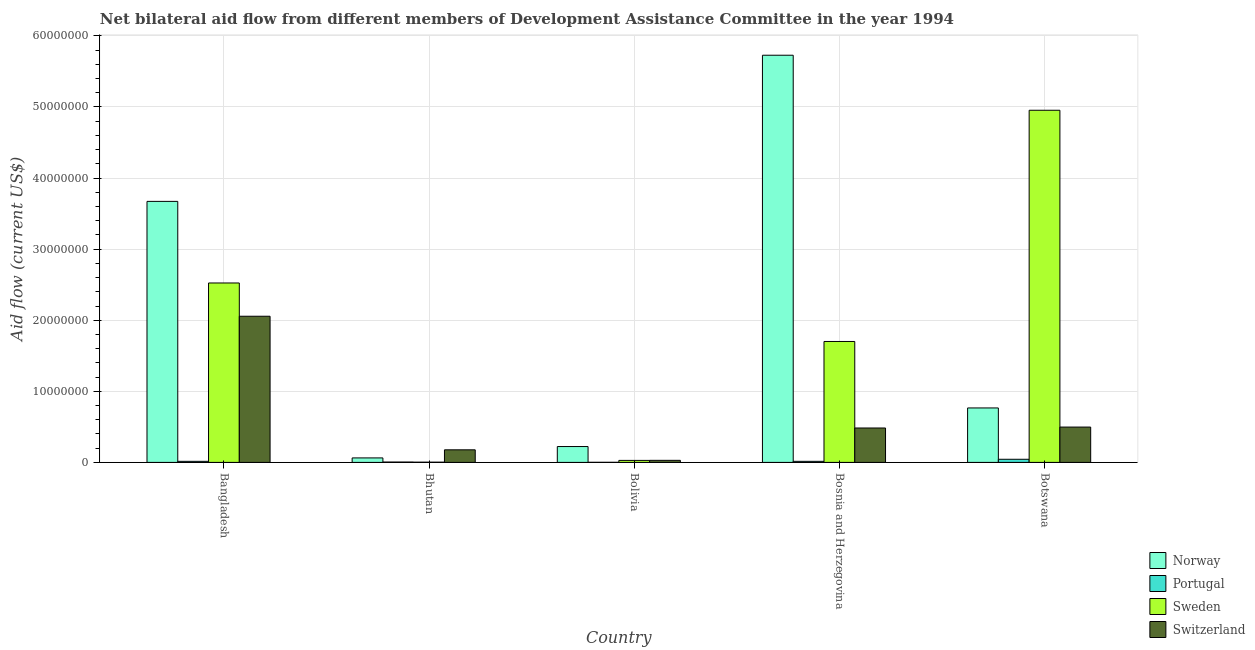How many different coloured bars are there?
Your answer should be compact. 4. Are the number of bars per tick equal to the number of legend labels?
Your answer should be very brief. Yes. How many bars are there on the 2nd tick from the left?
Offer a very short reply. 4. How many bars are there on the 3rd tick from the right?
Offer a very short reply. 4. What is the label of the 2nd group of bars from the left?
Give a very brief answer. Bhutan. What is the amount of aid given by norway in Bolivia?
Your answer should be compact. 2.23e+06. Across all countries, what is the maximum amount of aid given by portugal?
Ensure brevity in your answer.  4.40e+05. Across all countries, what is the minimum amount of aid given by norway?
Provide a succinct answer. 6.30e+05. In which country was the amount of aid given by portugal minimum?
Offer a terse response. Bolivia. What is the total amount of aid given by norway in the graph?
Offer a very short reply. 1.05e+08. What is the difference between the amount of aid given by norway in Bangladesh and that in Bhutan?
Keep it short and to the point. 3.61e+07. What is the difference between the amount of aid given by portugal in Bolivia and the amount of aid given by sweden in Bhutan?
Offer a very short reply. -2.00e+04. What is the average amount of aid given by sweden per country?
Give a very brief answer. 1.84e+07. What is the difference between the amount of aid given by switzerland and amount of aid given by norway in Botswana?
Your response must be concise. -2.69e+06. In how many countries, is the amount of aid given by norway greater than 18000000 US$?
Your answer should be compact. 2. What is the ratio of the amount of aid given by switzerland in Bhutan to that in Bosnia and Herzegovina?
Provide a short and direct response. 0.37. What is the difference between the highest and the second highest amount of aid given by switzerland?
Your answer should be very brief. 1.56e+07. What is the difference between the highest and the lowest amount of aid given by norway?
Your response must be concise. 5.66e+07. Is the sum of the amount of aid given by sweden in Bolivia and Bosnia and Herzegovina greater than the maximum amount of aid given by portugal across all countries?
Make the answer very short. Yes. Is it the case that in every country, the sum of the amount of aid given by sweden and amount of aid given by switzerland is greater than the sum of amount of aid given by norway and amount of aid given by portugal?
Provide a succinct answer. No. What does the 1st bar from the left in Bosnia and Herzegovina represents?
Your answer should be compact. Norway. What does the 1st bar from the right in Bhutan represents?
Make the answer very short. Switzerland. Is it the case that in every country, the sum of the amount of aid given by norway and amount of aid given by portugal is greater than the amount of aid given by sweden?
Ensure brevity in your answer.  No. How many bars are there?
Your answer should be compact. 20. Are all the bars in the graph horizontal?
Offer a terse response. No. How many countries are there in the graph?
Give a very brief answer. 5. What is the difference between two consecutive major ticks on the Y-axis?
Your response must be concise. 1.00e+07. Does the graph contain grids?
Offer a terse response. Yes. How many legend labels are there?
Provide a short and direct response. 4. How are the legend labels stacked?
Offer a terse response. Vertical. What is the title of the graph?
Your response must be concise. Net bilateral aid flow from different members of Development Assistance Committee in the year 1994. What is the Aid flow (current US$) of Norway in Bangladesh?
Provide a succinct answer. 3.67e+07. What is the Aid flow (current US$) in Sweden in Bangladesh?
Offer a very short reply. 2.52e+07. What is the Aid flow (current US$) in Switzerland in Bangladesh?
Offer a very short reply. 2.06e+07. What is the Aid flow (current US$) in Norway in Bhutan?
Offer a very short reply. 6.30e+05. What is the Aid flow (current US$) of Portugal in Bhutan?
Ensure brevity in your answer.  5.00e+04. What is the Aid flow (current US$) in Switzerland in Bhutan?
Give a very brief answer. 1.77e+06. What is the Aid flow (current US$) in Norway in Bolivia?
Ensure brevity in your answer.  2.23e+06. What is the Aid flow (current US$) of Portugal in Bolivia?
Offer a very short reply. 10000. What is the Aid flow (current US$) of Sweden in Bolivia?
Your answer should be compact. 2.80e+05. What is the Aid flow (current US$) of Norway in Bosnia and Herzegovina?
Offer a terse response. 5.73e+07. What is the Aid flow (current US$) of Portugal in Bosnia and Herzegovina?
Offer a terse response. 1.50e+05. What is the Aid flow (current US$) in Sweden in Bosnia and Herzegovina?
Provide a short and direct response. 1.70e+07. What is the Aid flow (current US$) of Switzerland in Bosnia and Herzegovina?
Provide a short and direct response. 4.84e+06. What is the Aid flow (current US$) of Norway in Botswana?
Your answer should be very brief. 7.66e+06. What is the Aid flow (current US$) of Sweden in Botswana?
Provide a short and direct response. 4.95e+07. What is the Aid flow (current US$) in Switzerland in Botswana?
Offer a very short reply. 4.97e+06. Across all countries, what is the maximum Aid flow (current US$) of Norway?
Your answer should be very brief. 5.73e+07. Across all countries, what is the maximum Aid flow (current US$) of Sweden?
Give a very brief answer. 4.95e+07. Across all countries, what is the maximum Aid flow (current US$) of Switzerland?
Your answer should be very brief. 2.06e+07. Across all countries, what is the minimum Aid flow (current US$) of Norway?
Your answer should be compact. 6.30e+05. Across all countries, what is the minimum Aid flow (current US$) of Portugal?
Ensure brevity in your answer.  10000. Across all countries, what is the minimum Aid flow (current US$) in Switzerland?
Your response must be concise. 2.90e+05. What is the total Aid flow (current US$) of Norway in the graph?
Make the answer very short. 1.05e+08. What is the total Aid flow (current US$) of Sweden in the graph?
Offer a very short reply. 9.21e+07. What is the total Aid flow (current US$) in Switzerland in the graph?
Offer a terse response. 3.24e+07. What is the difference between the Aid flow (current US$) in Norway in Bangladesh and that in Bhutan?
Ensure brevity in your answer.  3.61e+07. What is the difference between the Aid flow (current US$) in Sweden in Bangladesh and that in Bhutan?
Offer a terse response. 2.52e+07. What is the difference between the Aid flow (current US$) in Switzerland in Bangladesh and that in Bhutan?
Provide a succinct answer. 1.88e+07. What is the difference between the Aid flow (current US$) in Norway in Bangladesh and that in Bolivia?
Keep it short and to the point. 3.45e+07. What is the difference between the Aid flow (current US$) in Sweden in Bangladesh and that in Bolivia?
Your answer should be compact. 2.50e+07. What is the difference between the Aid flow (current US$) in Switzerland in Bangladesh and that in Bolivia?
Your answer should be very brief. 2.03e+07. What is the difference between the Aid flow (current US$) in Norway in Bangladesh and that in Bosnia and Herzegovina?
Give a very brief answer. -2.06e+07. What is the difference between the Aid flow (current US$) of Sweden in Bangladesh and that in Bosnia and Herzegovina?
Provide a short and direct response. 8.23e+06. What is the difference between the Aid flow (current US$) in Switzerland in Bangladesh and that in Bosnia and Herzegovina?
Keep it short and to the point. 1.57e+07. What is the difference between the Aid flow (current US$) of Norway in Bangladesh and that in Botswana?
Give a very brief answer. 2.91e+07. What is the difference between the Aid flow (current US$) in Portugal in Bangladesh and that in Botswana?
Offer a very short reply. -2.90e+05. What is the difference between the Aid flow (current US$) in Sweden in Bangladesh and that in Botswana?
Provide a succinct answer. -2.43e+07. What is the difference between the Aid flow (current US$) in Switzerland in Bangladesh and that in Botswana?
Offer a terse response. 1.56e+07. What is the difference between the Aid flow (current US$) in Norway in Bhutan and that in Bolivia?
Make the answer very short. -1.60e+06. What is the difference between the Aid flow (current US$) in Switzerland in Bhutan and that in Bolivia?
Keep it short and to the point. 1.48e+06. What is the difference between the Aid flow (current US$) of Norway in Bhutan and that in Bosnia and Herzegovina?
Provide a succinct answer. -5.66e+07. What is the difference between the Aid flow (current US$) in Portugal in Bhutan and that in Bosnia and Herzegovina?
Make the answer very short. -1.00e+05. What is the difference between the Aid flow (current US$) in Sweden in Bhutan and that in Bosnia and Herzegovina?
Offer a terse response. -1.70e+07. What is the difference between the Aid flow (current US$) of Switzerland in Bhutan and that in Bosnia and Herzegovina?
Your answer should be very brief. -3.07e+06. What is the difference between the Aid flow (current US$) of Norway in Bhutan and that in Botswana?
Your answer should be compact. -7.03e+06. What is the difference between the Aid flow (current US$) of Portugal in Bhutan and that in Botswana?
Ensure brevity in your answer.  -3.90e+05. What is the difference between the Aid flow (current US$) in Sweden in Bhutan and that in Botswana?
Offer a terse response. -4.95e+07. What is the difference between the Aid flow (current US$) of Switzerland in Bhutan and that in Botswana?
Provide a succinct answer. -3.20e+06. What is the difference between the Aid flow (current US$) of Norway in Bolivia and that in Bosnia and Herzegovina?
Provide a succinct answer. -5.50e+07. What is the difference between the Aid flow (current US$) in Sweden in Bolivia and that in Bosnia and Herzegovina?
Offer a terse response. -1.67e+07. What is the difference between the Aid flow (current US$) in Switzerland in Bolivia and that in Bosnia and Herzegovina?
Offer a terse response. -4.55e+06. What is the difference between the Aid flow (current US$) in Norway in Bolivia and that in Botswana?
Your answer should be very brief. -5.43e+06. What is the difference between the Aid flow (current US$) of Portugal in Bolivia and that in Botswana?
Your response must be concise. -4.30e+05. What is the difference between the Aid flow (current US$) in Sweden in Bolivia and that in Botswana?
Give a very brief answer. -4.93e+07. What is the difference between the Aid flow (current US$) of Switzerland in Bolivia and that in Botswana?
Ensure brevity in your answer.  -4.68e+06. What is the difference between the Aid flow (current US$) of Norway in Bosnia and Herzegovina and that in Botswana?
Your response must be concise. 4.96e+07. What is the difference between the Aid flow (current US$) in Sweden in Bosnia and Herzegovina and that in Botswana?
Offer a terse response. -3.25e+07. What is the difference between the Aid flow (current US$) in Switzerland in Bosnia and Herzegovina and that in Botswana?
Provide a short and direct response. -1.30e+05. What is the difference between the Aid flow (current US$) of Norway in Bangladesh and the Aid flow (current US$) of Portugal in Bhutan?
Give a very brief answer. 3.67e+07. What is the difference between the Aid flow (current US$) of Norway in Bangladesh and the Aid flow (current US$) of Sweden in Bhutan?
Offer a terse response. 3.67e+07. What is the difference between the Aid flow (current US$) in Norway in Bangladesh and the Aid flow (current US$) in Switzerland in Bhutan?
Give a very brief answer. 3.50e+07. What is the difference between the Aid flow (current US$) in Portugal in Bangladesh and the Aid flow (current US$) in Switzerland in Bhutan?
Provide a short and direct response. -1.62e+06. What is the difference between the Aid flow (current US$) in Sweden in Bangladesh and the Aid flow (current US$) in Switzerland in Bhutan?
Offer a terse response. 2.35e+07. What is the difference between the Aid flow (current US$) of Norway in Bangladesh and the Aid flow (current US$) of Portugal in Bolivia?
Your answer should be compact. 3.67e+07. What is the difference between the Aid flow (current US$) in Norway in Bangladesh and the Aid flow (current US$) in Sweden in Bolivia?
Give a very brief answer. 3.64e+07. What is the difference between the Aid flow (current US$) of Norway in Bangladesh and the Aid flow (current US$) of Switzerland in Bolivia?
Your answer should be compact. 3.64e+07. What is the difference between the Aid flow (current US$) in Sweden in Bangladesh and the Aid flow (current US$) in Switzerland in Bolivia?
Make the answer very short. 2.50e+07. What is the difference between the Aid flow (current US$) in Norway in Bangladesh and the Aid flow (current US$) in Portugal in Bosnia and Herzegovina?
Give a very brief answer. 3.66e+07. What is the difference between the Aid flow (current US$) in Norway in Bangladesh and the Aid flow (current US$) in Sweden in Bosnia and Herzegovina?
Provide a short and direct response. 1.97e+07. What is the difference between the Aid flow (current US$) in Norway in Bangladesh and the Aid flow (current US$) in Switzerland in Bosnia and Herzegovina?
Offer a terse response. 3.19e+07. What is the difference between the Aid flow (current US$) of Portugal in Bangladesh and the Aid flow (current US$) of Sweden in Bosnia and Herzegovina?
Your answer should be very brief. -1.69e+07. What is the difference between the Aid flow (current US$) of Portugal in Bangladesh and the Aid flow (current US$) of Switzerland in Bosnia and Herzegovina?
Make the answer very short. -4.69e+06. What is the difference between the Aid flow (current US$) of Sweden in Bangladesh and the Aid flow (current US$) of Switzerland in Bosnia and Herzegovina?
Provide a short and direct response. 2.04e+07. What is the difference between the Aid flow (current US$) in Norway in Bangladesh and the Aid flow (current US$) in Portugal in Botswana?
Provide a short and direct response. 3.63e+07. What is the difference between the Aid flow (current US$) of Norway in Bangladesh and the Aid flow (current US$) of Sweden in Botswana?
Your answer should be compact. -1.28e+07. What is the difference between the Aid flow (current US$) of Norway in Bangladesh and the Aid flow (current US$) of Switzerland in Botswana?
Your response must be concise. 3.18e+07. What is the difference between the Aid flow (current US$) in Portugal in Bangladesh and the Aid flow (current US$) in Sweden in Botswana?
Give a very brief answer. -4.94e+07. What is the difference between the Aid flow (current US$) of Portugal in Bangladesh and the Aid flow (current US$) of Switzerland in Botswana?
Offer a terse response. -4.82e+06. What is the difference between the Aid flow (current US$) in Sweden in Bangladesh and the Aid flow (current US$) in Switzerland in Botswana?
Give a very brief answer. 2.03e+07. What is the difference between the Aid flow (current US$) in Norway in Bhutan and the Aid flow (current US$) in Portugal in Bolivia?
Give a very brief answer. 6.20e+05. What is the difference between the Aid flow (current US$) in Norway in Bhutan and the Aid flow (current US$) in Sweden in Bolivia?
Your response must be concise. 3.50e+05. What is the difference between the Aid flow (current US$) in Norway in Bhutan and the Aid flow (current US$) in Switzerland in Bolivia?
Ensure brevity in your answer.  3.40e+05. What is the difference between the Aid flow (current US$) in Portugal in Bhutan and the Aid flow (current US$) in Switzerland in Bolivia?
Your response must be concise. -2.40e+05. What is the difference between the Aid flow (current US$) in Sweden in Bhutan and the Aid flow (current US$) in Switzerland in Bolivia?
Keep it short and to the point. -2.60e+05. What is the difference between the Aid flow (current US$) of Norway in Bhutan and the Aid flow (current US$) of Portugal in Bosnia and Herzegovina?
Ensure brevity in your answer.  4.80e+05. What is the difference between the Aid flow (current US$) of Norway in Bhutan and the Aid flow (current US$) of Sweden in Bosnia and Herzegovina?
Make the answer very short. -1.64e+07. What is the difference between the Aid flow (current US$) in Norway in Bhutan and the Aid flow (current US$) in Switzerland in Bosnia and Herzegovina?
Your answer should be very brief. -4.21e+06. What is the difference between the Aid flow (current US$) of Portugal in Bhutan and the Aid flow (current US$) of Sweden in Bosnia and Herzegovina?
Offer a very short reply. -1.70e+07. What is the difference between the Aid flow (current US$) of Portugal in Bhutan and the Aid flow (current US$) of Switzerland in Bosnia and Herzegovina?
Your answer should be compact. -4.79e+06. What is the difference between the Aid flow (current US$) of Sweden in Bhutan and the Aid flow (current US$) of Switzerland in Bosnia and Herzegovina?
Ensure brevity in your answer.  -4.81e+06. What is the difference between the Aid flow (current US$) of Norway in Bhutan and the Aid flow (current US$) of Portugal in Botswana?
Your response must be concise. 1.90e+05. What is the difference between the Aid flow (current US$) of Norway in Bhutan and the Aid flow (current US$) of Sweden in Botswana?
Ensure brevity in your answer.  -4.89e+07. What is the difference between the Aid flow (current US$) in Norway in Bhutan and the Aid flow (current US$) in Switzerland in Botswana?
Give a very brief answer. -4.34e+06. What is the difference between the Aid flow (current US$) of Portugal in Bhutan and the Aid flow (current US$) of Sweden in Botswana?
Offer a very short reply. -4.95e+07. What is the difference between the Aid flow (current US$) of Portugal in Bhutan and the Aid flow (current US$) of Switzerland in Botswana?
Your response must be concise. -4.92e+06. What is the difference between the Aid flow (current US$) in Sweden in Bhutan and the Aid flow (current US$) in Switzerland in Botswana?
Your answer should be compact. -4.94e+06. What is the difference between the Aid flow (current US$) of Norway in Bolivia and the Aid flow (current US$) of Portugal in Bosnia and Herzegovina?
Keep it short and to the point. 2.08e+06. What is the difference between the Aid flow (current US$) of Norway in Bolivia and the Aid flow (current US$) of Sweden in Bosnia and Herzegovina?
Your answer should be compact. -1.48e+07. What is the difference between the Aid flow (current US$) in Norway in Bolivia and the Aid flow (current US$) in Switzerland in Bosnia and Herzegovina?
Your answer should be compact. -2.61e+06. What is the difference between the Aid flow (current US$) in Portugal in Bolivia and the Aid flow (current US$) in Sweden in Bosnia and Herzegovina?
Keep it short and to the point. -1.70e+07. What is the difference between the Aid flow (current US$) of Portugal in Bolivia and the Aid flow (current US$) of Switzerland in Bosnia and Herzegovina?
Make the answer very short. -4.83e+06. What is the difference between the Aid flow (current US$) of Sweden in Bolivia and the Aid flow (current US$) of Switzerland in Bosnia and Herzegovina?
Keep it short and to the point. -4.56e+06. What is the difference between the Aid flow (current US$) in Norway in Bolivia and the Aid flow (current US$) in Portugal in Botswana?
Offer a terse response. 1.79e+06. What is the difference between the Aid flow (current US$) in Norway in Bolivia and the Aid flow (current US$) in Sweden in Botswana?
Make the answer very short. -4.73e+07. What is the difference between the Aid flow (current US$) of Norway in Bolivia and the Aid flow (current US$) of Switzerland in Botswana?
Provide a succinct answer. -2.74e+06. What is the difference between the Aid flow (current US$) of Portugal in Bolivia and the Aid flow (current US$) of Sweden in Botswana?
Your response must be concise. -4.95e+07. What is the difference between the Aid flow (current US$) of Portugal in Bolivia and the Aid flow (current US$) of Switzerland in Botswana?
Offer a terse response. -4.96e+06. What is the difference between the Aid flow (current US$) of Sweden in Bolivia and the Aid flow (current US$) of Switzerland in Botswana?
Provide a short and direct response. -4.69e+06. What is the difference between the Aid flow (current US$) of Norway in Bosnia and Herzegovina and the Aid flow (current US$) of Portugal in Botswana?
Ensure brevity in your answer.  5.68e+07. What is the difference between the Aid flow (current US$) of Norway in Bosnia and Herzegovina and the Aid flow (current US$) of Sweden in Botswana?
Make the answer very short. 7.74e+06. What is the difference between the Aid flow (current US$) in Norway in Bosnia and Herzegovina and the Aid flow (current US$) in Switzerland in Botswana?
Keep it short and to the point. 5.23e+07. What is the difference between the Aid flow (current US$) of Portugal in Bosnia and Herzegovina and the Aid flow (current US$) of Sweden in Botswana?
Make the answer very short. -4.94e+07. What is the difference between the Aid flow (current US$) of Portugal in Bosnia and Herzegovina and the Aid flow (current US$) of Switzerland in Botswana?
Offer a very short reply. -4.82e+06. What is the difference between the Aid flow (current US$) in Sweden in Bosnia and Herzegovina and the Aid flow (current US$) in Switzerland in Botswana?
Offer a terse response. 1.20e+07. What is the average Aid flow (current US$) of Norway per country?
Your response must be concise. 2.09e+07. What is the average Aid flow (current US$) in Portugal per country?
Offer a very short reply. 1.60e+05. What is the average Aid flow (current US$) in Sweden per country?
Make the answer very short. 1.84e+07. What is the average Aid flow (current US$) of Switzerland per country?
Provide a short and direct response. 6.49e+06. What is the difference between the Aid flow (current US$) of Norway and Aid flow (current US$) of Portugal in Bangladesh?
Give a very brief answer. 3.66e+07. What is the difference between the Aid flow (current US$) in Norway and Aid flow (current US$) in Sweden in Bangladesh?
Your answer should be very brief. 1.15e+07. What is the difference between the Aid flow (current US$) in Norway and Aid flow (current US$) in Switzerland in Bangladesh?
Offer a very short reply. 1.62e+07. What is the difference between the Aid flow (current US$) in Portugal and Aid flow (current US$) in Sweden in Bangladesh?
Ensure brevity in your answer.  -2.51e+07. What is the difference between the Aid flow (current US$) of Portugal and Aid flow (current US$) of Switzerland in Bangladesh?
Keep it short and to the point. -2.04e+07. What is the difference between the Aid flow (current US$) in Sweden and Aid flow (current US$) in Switzerland in Bangladesh?
Provide a short and direct response. 4.68e+06. What is the difference between the Aid flow (current US$) in Norway and Aid flow (current US$) in Portugal in Bhutan?
Give a very brief answer. 5.80e+05. What is the difference between the Aid flow (current US$) in Norway and Aid flow (current US$) in Switzerland in Bhutan?
Ensure brevity in your answer.  -1.14e+06. What is the difference between the Aid flow (current US$) of Portugal and Aid flow (current US$) of Switzerland in Bhutan?
Give a very brief answer. -1.72e+06. What is the difference between the Aid flow (current US$) in Sweden and Aid flow (current US$) in Switzerland in Bhutan?
Your answer should be very brief. -1.74e+06. What is the difference between the Aid flow (current US$) in Norway and Aid flow (current US$) in Portugal in Bolivia?
Your response must be concise. 2.22e+06. What is the difference between the Aid flow (current US$) in Norway and Aid flow (current US$) in Sweden in Bolivia?
Make the answer very short. 1.95e+06. What is the difference between the Aid flow (current US$) of Norway and Aid flow (current US$) of Switzerland in Bolivia?
Your answer should be compact. 1.94e+06. What is the difference between the Aid flow (current US$) of Portugal and Aid flow (current US$) of Sweden in Bolivia?
Provide a succinct answer. -2.70e+05. What is the difference between the Aid flow (current US$) in Portugal and Aid flow (current US$) in Switzerland in Bolivia?
Your response must be concise. -2.80e+05. What is the difference between the Aid flow (current US$) in Sweden and Aid flow (current US$) in Switzerland in Bolivia?
Offer a terse response. -10000. What is the difference between the Aid flow (current US$) of Norway and Aid flow (current US$) of Portugal in Bosnia and Herzegovina?
Provide a short and direct response. 5.71e+07. What is the difference between the Aid flow (current US$) of Norway and Aid flow (current US$) of Sweden in Bosnia and Herzegovina?
Ensure brevity in your answer.  4.03e+07. What is the difference between the Aid flow (current US$) of Norway and Aid flow (current US$) of Switzerland in Bosnia and Herzegovina?
Offer a very short reply. 5.24e+07. What is the difference between the Aid flow (current US$) of Portugal and Aid flow (current US$) of Sweden in Bosnia and Herzegovina?
Keep it short and to the point. -1.69e+07. What is the difference between the Aid flow (current US$) in Portugal and Aid flow (current US$) in Switzerland in Bosnia and Herzegovina?
Keep it short and to the point. -4.69e+06. What is the difference between the Aid flow (current US$) in Sweden and Aid flow (current US$) in Switzerland in Bosnia and Herzegovina?
Ensure brevity in your answer.  1.22e+07. What is the difference between the Aid flow (current US$) in Norway and Aid flow (current US$) in Portugal in Botswana?
Your answer should be very brief. 7.22e+06. What is the difference between the Aid flow (current US$) in Norway and Aid flow (current US$) in Sweden in Botswana?
Your answer should be compact. -4.19e+07. What is the difference between the Aid flow (current US$) of Norway and Aid flow (current US$) of Switzerland in Botswana?
Provide a succinct answer. 2.69e+06. What is the difference between the Aid flow (current US$) in Portugal and Aid flow (current US$) in Sweden in Botswana?
Ensure brevity in your answer.  -4.91e+07. What is the difference between the Aid flow (current US$) of Portugal and Aid flow (current US$) of Switzerland in Botswana?
Provide a succinct answer. -4.53e+06. What is the difference between the Aid flow (current US$) of Sweden and Aid flow (current US$) of Switzerland in Botswana?
Your answer should be compact. 4.46e+07. What is the ratio of the Aid flow (current US$) in Norway in Bangladesh to that in Bhutan?
Your response must be concise. 58.29. What is the ratio of the Aid flow (current US$) in Portugal in Bangladesh to that in Bhutan?
Ensure brevity in your answer.  3. What is the ratio of the Aid flow (current US$) in Sweden in Bangladesh to that in Bhutan?
Ensure brevity in your answer.  841.33. What is the ratio of the Aid flow (current US$) of Switzerland in Bangladesh to that in Bhutan?
Keep it short and to the point. 11.62. What is the ratio of the Aid flow (current US$) of Norway in Bangladesh to that in Bolivia?
Offer a very short reply. 16.47. What is the ratio of the Aid flow (current US$) in Sweden in Bangladesh to that in Bolivia?
Keep it short and to the point. 90.14. What is the ratio of the Aid flow (current US$) in Switzerland in Bangladesh to that in Bolivia?
Keep it short and to the point. 70.9. What is the ratio of the Aid flow (current US$) in Norway in Bangladesh to that in Bosnia and Herzegovina?
Offer a very short reply. 0.64. What is the ratio of the Aid flow (current US$) in Portugal in Bangladesh to that in Bosnia and Herzegovina?
Offer a terse response. 1. What is the ratio of the Aid flow (current US$) in Sweden in Bangladesh to that in Bosnia and Herzegovina?
Provide a short and direct response. 1.48. What is the ratio of the Aid flow (current US$) in Switzerland in Bangladesh to that in Bosnia and Herzegovina?
Offer a terse response. 4.25. What is the ratio of the Aid flow (current US$) in Norway in Bangladesh to that in Botswana?
Make the answer very short. 4.79. What is the ratio of the Aid flow (current US$) in Portugal in Bangladesh to that in Botswana?
Ensure brevity in your answer.  0.34. What is the ratio of the Aid flow (current US$) of Sweden in Bangladesh to that in Botswana?
Keep it short and to the point. 0.51. What is the ratio of the Aid flow (current US$) of Switzerland in Bangladesh to that in Botswana?
Provide a short and direct response. 4.14. What is the ratio of the Aid flow (current US$) of Norway in Bhutan to that in Bolivia?
Your answer should be very brief. 0.28. What is the ratio of the Aid flow (current US$) of Portugal in Bhutan to that in Bolivia?
Provide a short and direct response. 5. What is the ratio of the Aid flow (current US$) in Sweden in Bhutan to that in Bolivia?
Keep it short and to the point. 0.11. What is the ratio of the Aid flow (current US$) in Switzerland in Bhutan to that in Bolivia?
Provide a short and direct response. 6.1. What is the ratio of the Aid flow (current US$) in Norway in Bhutan to that in Bosnia and Herzegovina?
Ensure brevity in your answer.  0.01. What is the ratio of the Aid flow (current US$) in Sweden in Bhutan to that in Bosnia and Herzegovina?
Give a very brief answer. 0. What is the ratio of the Aid flow (current US$) in Switzerland in Bhutan to that in Bosnia and Herzegovina?
Ensure brevity in your answer.  0.37. What is the ratio of the Aid flow (current US$) in Norway in Bhutan to that in Botswana?
Offer a very short reply. 0.08. What is the ratio of the Aid flow (current US$) in Portugal in Bhutan to that in Botswana?
Give a very brief answer. 0.11. What is the ratio of the Aid flow (current US$) of Sweden in Bhutan to that in Botswana?
Offer a very short reply. 0. What is the ratio of the Aid flow (current US$) of Switzerland in Bhutan to that in Botswana?
Your answer should be very brief. 0.36. What is the ratio of the Aid flow (current US$) of Norway in Bolivia to that in Bosnia and Herzegovina?
Your answer should be very brief. 0.04. What is the ratio of the Aid flow (current US$) in Portugal in Bolivia to that in Bosnia and Herzegovina?
Provide a succinct answer. 0.07. What is the ratio of the Aid flow (current US$) in Sweden in Bolivia to that in Bosnia and Herzegovina?
Your answer should be compact. 0.02. What is the ratio of the Aid flow (current US$) of Switzerland in Bolivia to that in Bosnia and Herzegovina?
Ensure brevity in your answer.  0.06. What is the ratio of the Aid flow (current US$) of Norway in Bolivia to that in Botswana?
Give a very brief answer. 0.29. What is the ratio of the Aid flow (current US$) of Portugal in Bolivia to that in Botswana?
Offer a terse response. 0.02. What is the ratio of the Aid flow (current US$) in Sweden in Bolivia to that in Botswana?
Your response must be concise. 0.01. What is the ratio of the Aid flow (current US$) of Switzerland in Bolivia to that in Botswana?
Your response must be concise. 0.06. What is the ratio of the Aid flow (current US$) of Norway in Bosnia and Herzegovina to that in Botswana?
Your answer should be compact. 7.48. What is the ratio of the Aid flow (current US$) in Portugal in Bosnia and Herzegovina to that in Botswana?
Make the answer very short. 0.34. What is the ratio of the Aid flow (current US$) of Sweden in Bosnia and Herzegovina to that in Botswana?
Make the answer very short. 0.34. What is the ratio of the Aid flow (current US$) in Switzerland in Bosnia and Herzegovina to that in Botswana?
Provide a short and direct response. 0.97. What is the difference between the highest and the second highest Aid flow (current US$) of Norway?
Offer a terse response. 2.06e+07. What is the difference between the highest and the second highest Aid flow (current US$) of Portugal?
Offer a terse response. 2.90e+05. What is the difference between the highest and the second highest Aid flow (current US$) of Sweden?
Provide a short and direct response. 2.43e+07. What is the difference between the highest and the second highest Aid flow (current US$) of Switzerland?
Make the answer very short. 1.56e+07. What is the difference between the highest and the lowest Aid flow (current US$) in Norway?
Ensure brevity in your answer.  5.66e+07. What is the difference between the highest and the lowest Aid flow (current US$) in Portugal?
Your answer should be compact. 4.30e+05. What is the difference between the highest and the lowest Aid flow (current US$) of Sweden?
Ensure brevity in your answer.  4.95e+07. What is the difference between the highest and the lowest Aid flow (current US$) in Switzerland?
Make the answer very short. 2.03e+07. 